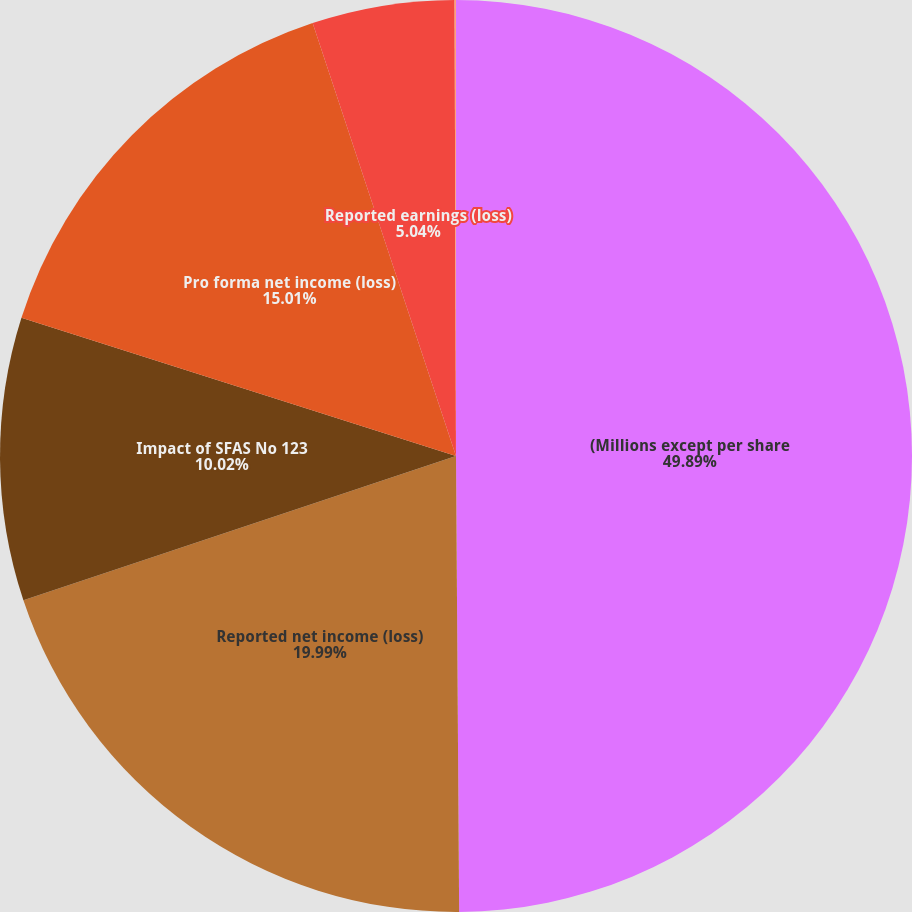<chart> <loc_0><loc_0><loc_500><loc_500><pie_chart><fcel>(Millions except per share<fcel>Reported net income (loss)<fcel>Impact of SFAS No 123<fcel>Pro forma net income (loss)<fcel>Reported earnings (loss)<fcel>Pro forma earnings (loss)<nl><fcel>49.89%<fcel>19.99%<fcel>10.02%<fcel>15.01%<fcel>5.04%<fcel>0.05%<nl></chart> 